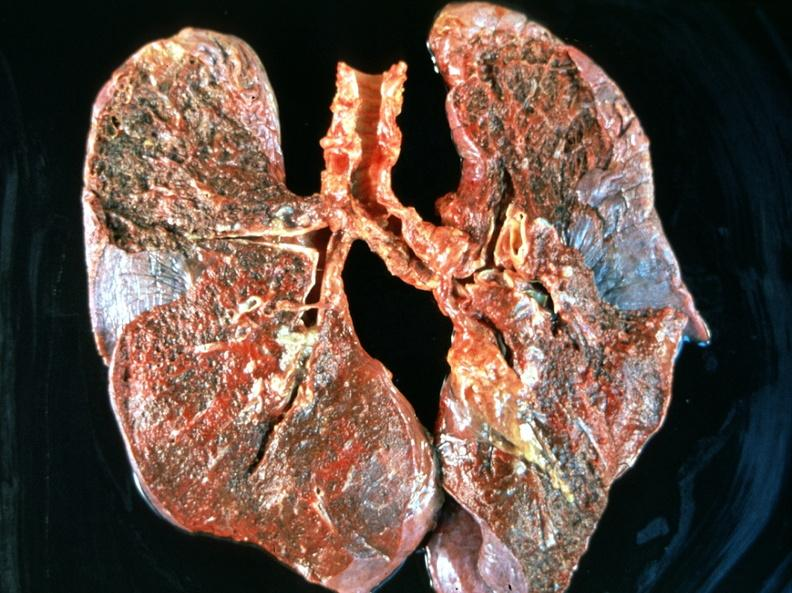s metastatic malignant melanoma present?
Answer the question using a single word or phrase. No 